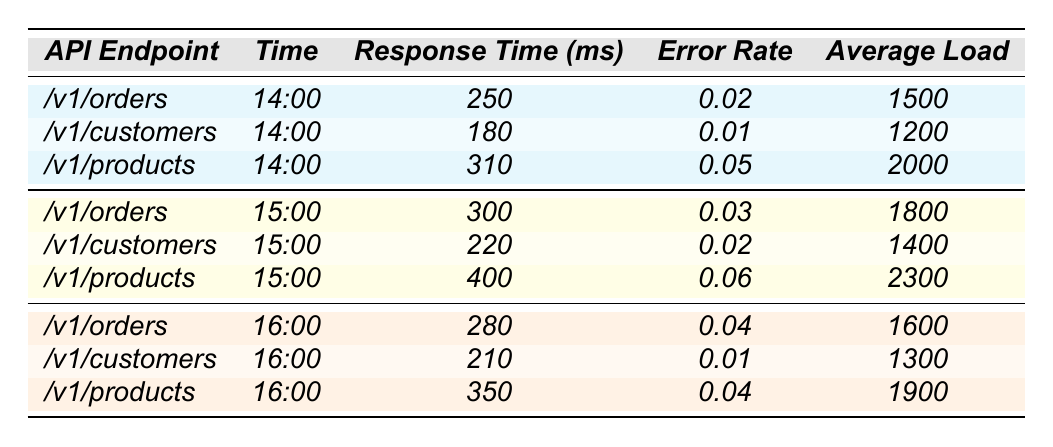What is the response time for the API endpoint /v1/customers at 14:00? According to the table, the response time for the /v1/customers endpoint at 14:00 is listed as 180 milliseconds.
Answer: 180 ms What is the error rate for the /v1/products API at 16:00? The table shows that the error rate for the /v1/products endpoint at 16:00 is 0.04.
Answer: 0.04 Which API endpoint had the highest response time during the 15:00 hour? By comparing the response times of all endpoints at 15:00, the /v1/products API has the highest response time of 400 milliseconds.
Answer: /v1/products What is the average response time across all API calls at 14:00? The response times at 14:00 are 250 ms, 180 ms, and 310 ms. The average is (250 + 180 + 310) / 3 = 246.67 ms, which is approximately 247 ms.
Answer: 247 ms Was the error rate for the /v1/orders API lower at 14:00 compared to 15:00? The error rate for /v1/orders at 14:00 is 0.02, while at 15:00 it is 0.03. Since 0.02 is less than 0.03, the error rate was lower at 14:00.
Answer: Yes What is the total average load for all API endpoints at 16:00? The average loads at 16:00 are 1600, 1300, and 1900. Adding these together gives 1600 + 1300 + 1900 = 4800.
Answer: 4800 How did the response time for /v1/orders change from 14:00 to 16:00? At 14:00, the response time for /v1/orders is 250 ms, and at 16:00 it is 280 ms. The change is an increase of 30 ms.
Answer: Increased by 30 ms Which API endpoint had the lowest error rate over the observed hours? Examining the error rates for all endpoints across all times, /v1/customers at 14:00 had the lowest error rate of 0.01.
Answer: /v1/customers What was the average response time for the /v1/products API across all three hours? The response times for /v1/products are 310 ms at 14:00, 400 ms at 15:00, and 350 ms at 16:00. The average is (310 + 400 + 350) / 3 = 353.33 ms, which rounds to approximately 353 ms.
Answer: 353 ms At which hour did the /v1/customers API reach its highest response time? Looking at the response times, the highest response time for /v1/customers was at 15:00 with 220 ms.
Answer: 15:00 